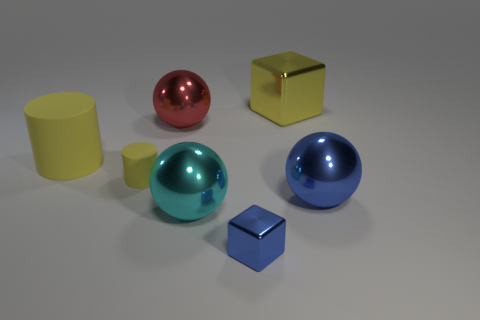Does the tiny cylinder have the same color as the shiny cube behind the cyan thing?
Give a very brief answer. Yes. There is a big block that is the same color as the large cylinder; what is it made of?
Make the answer very short. Metal. What number of other objects are there of the same color as the small cylinder?
Your response must be concise. 2. What is the tiny block that is in front of the large cyan metallic thing that is to the right of the small thing left of the small blue shiny object made of?
Provide a succinct answer. Metal. There is a block that is behind the large ball right of the tiny blue metal cube; what is its material?
Give a very brief answer. Metal. Are there fewer balls behind the tiny blue object than tiny red matte objects?
Keep it short and to the point. No. There is a yellow thing behind the big yellow matte cylinder; what is its shape?
Give a very brief answer. Cube. Does the red metallic sphere have the same size as the block in front of the small yellow rubber cylinder?
Your response must be concise. No. Is there a blue sphere made of the same material as the small block?
Your answer should be compact. Yes. How many balls are either large rubber things or blue things?
Your answer should be compact. 1. 